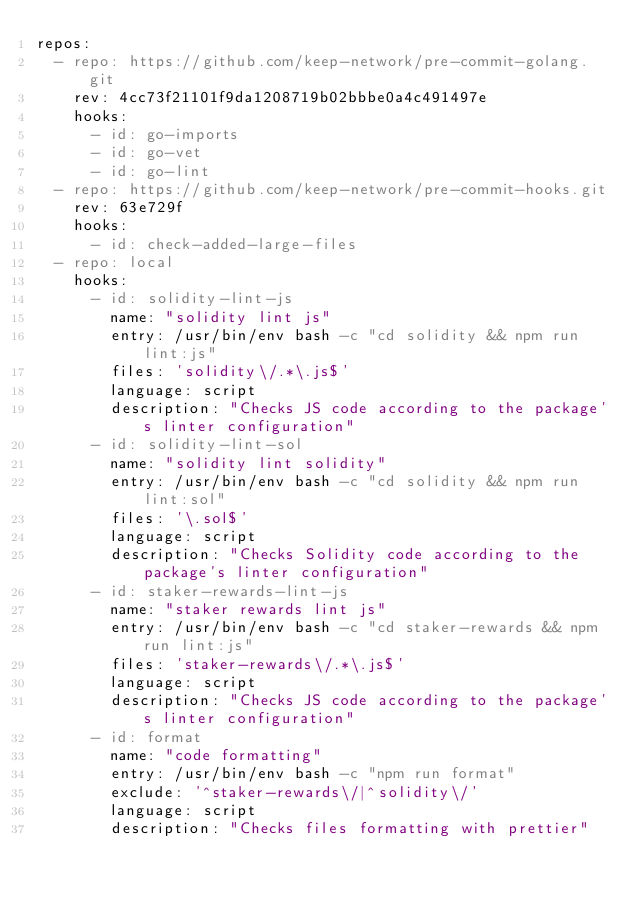<code> <loc_0><loc_0><loc_500><loc_500><_YAML_>repos:
  - repo: https://github.com/keep-network/pre-commit-golang.git
    rev: 4cc73f21101f9da1208719b02bbbe0a4c491497e
    hooks:
      - id: go-imports
      - id: go-vet
      - id: go-lint
  - repo: https://github.com/keep-network/pre-commit-hooks.git
    rev: 63e729f
    hooks:
      - id: check-added-large-files
  - repo: local
    hooks:
      - id: solidity-lint-js
        name: "solidity lint js"
        entry: /usr/bin/env bash -c "cd solidity && npm run lint:js"
        files: 'solidity\/.*\.js$'
        language: script
        description: "Checks JS code according to the package's linter configuration"
      - id: solidity-lint-sol
        name: "solidity lint solidity"
        entry: /usr/bin/env bash -c "cd solidity && npm run lint:sol"
        files: '\.sol$'
        language: script
        description: "Checks Solidity code according to the package's linter configuration"
      - id: staker-rewards-lint-js
        name: "staker rewards lint js"
        entry: /usr/bin/env bash -c "cd staker-rewards && npm run lint:js"
        files: 'staker-rewards\/.*\.js$'
        language: script
        description: "Checks JS code according to the package's linter configuration"
      - id: format
        name: "code formatting"
        entry: /usr/bin/env bash -c "npm run format"
        exclude: '^staker-rewards\/|^solidity\/'
        language: script
        description: "Checks files formatting with prettier"
</code> 